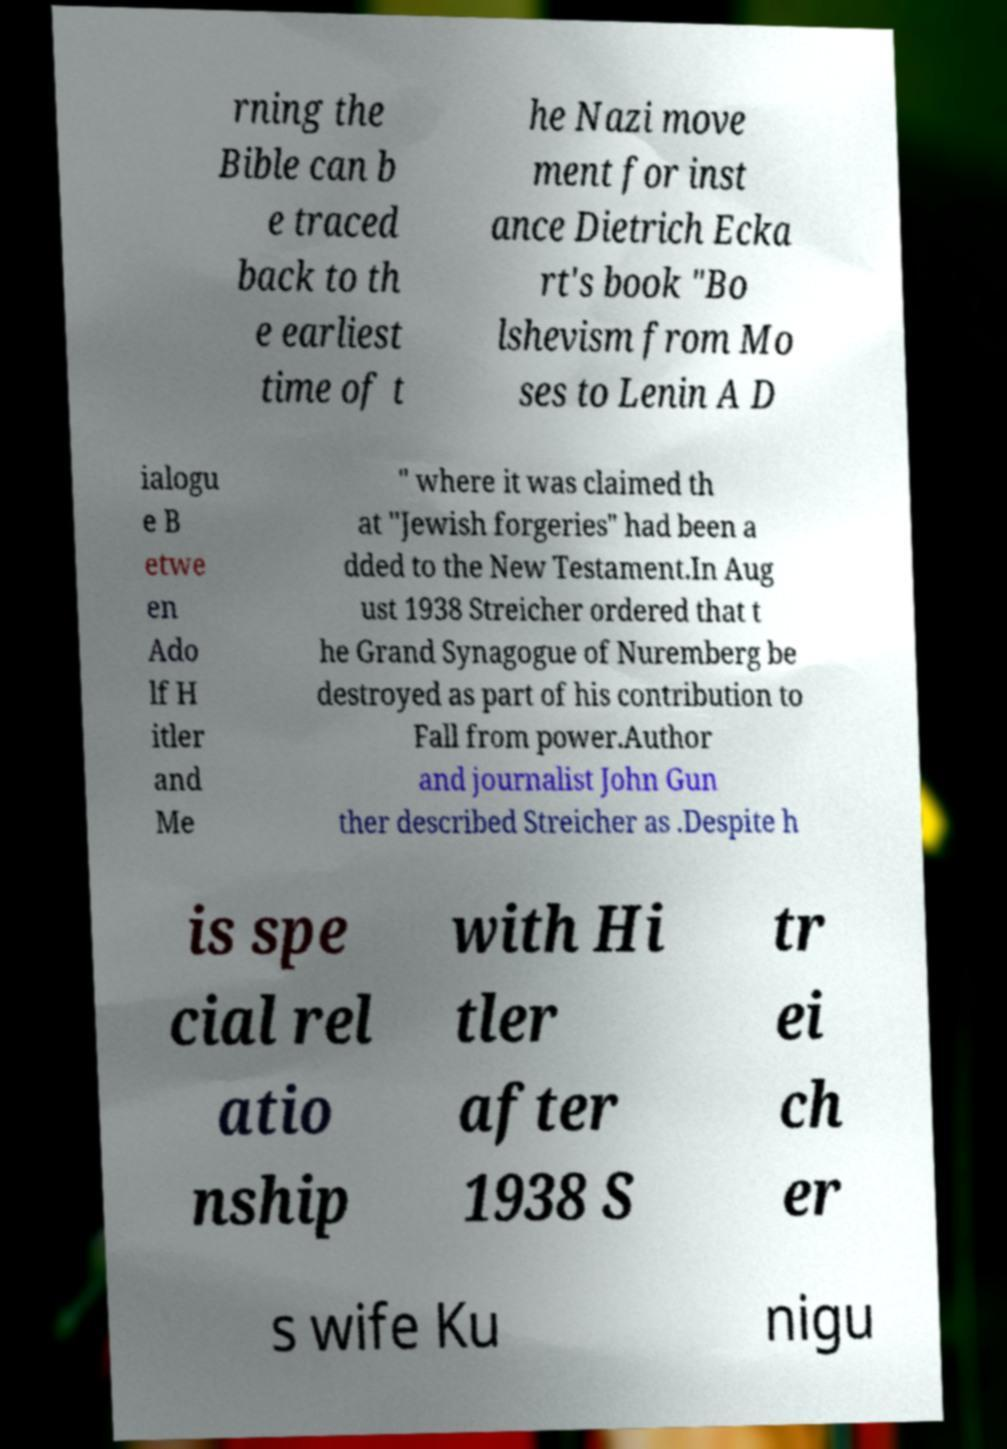What messages or text are displayed in this image? I need them in a readable, typed format. rning the Bible can b e traced back to th e earliest time of t he Nazi move ment for inst ance Dietrich Ecka rt's book "Bo lshevism from Mo ses to Lenin A D ialogu e B etwe en Ado lf H itler and Me " where it was claimed th at "Jewish forgeries" had been a dded to the New Testament.In Aug ust 1938 Streicher ordered that t he Grand Synagogue of Nuremberg be destroyed as part of his contribution to Fall from power.Author and journalist John Gun ther described Streicher as .Despite h is spe cial rel atio nship with Hi tler after 1938 S tr ei ch er s wife Ku nigu 